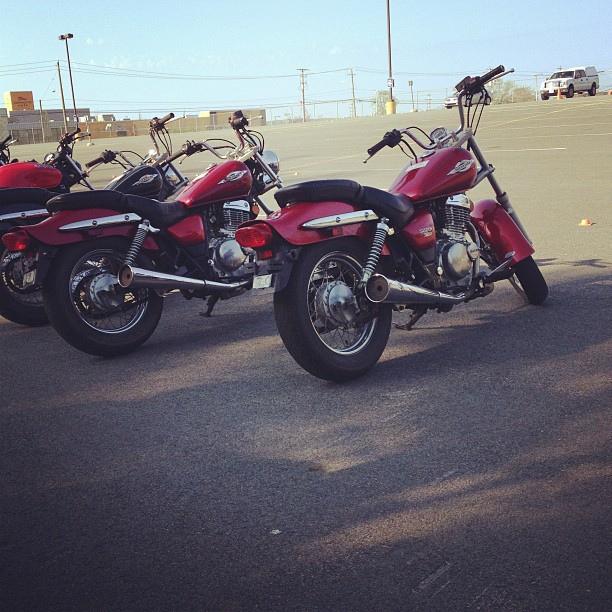Are these bikes for sale?
Short answer required. No. What color is the truck in the background?
Give a very brief answer. White. Do these motorcycles appear to be the same make?
Give a very brief answer. Yes. 